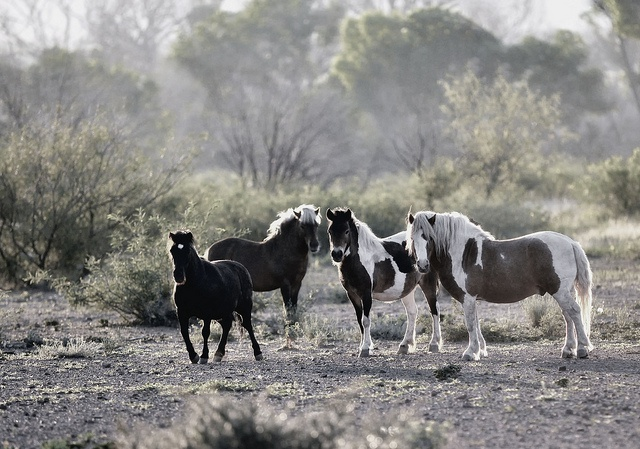Describe the objects in this image and their specific colors. I can see horse in white, darkgray, black, gray, and lightgray tones, horse in white, black, darkgray, gray, and lightgray tones, horse in white, black, gray, darkgray, and lightgray tones, and horse in white, black, gray, and darkgray tones in this image. 